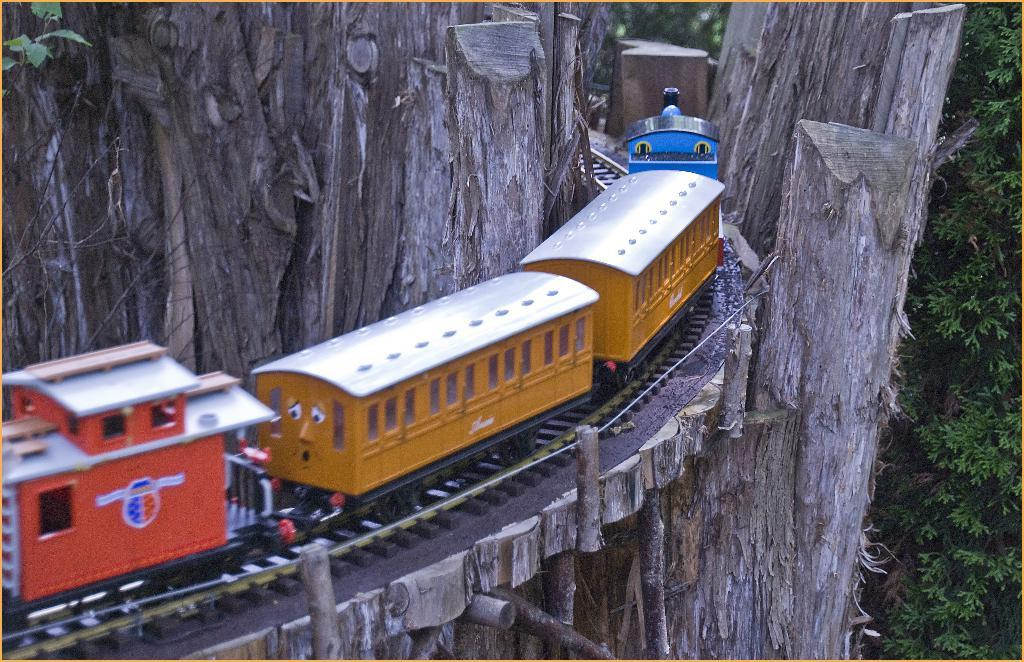What is the main subject of the image? There is a kids train in the image. What is the train doing in the image? The train is moving on a track. How is the track positioned in the image? The track is between tree trunks. What can be seen on the right side of the image? There are leaves on the right side of the image. What type of plants can be seen growing on the boundary of the image? There is no boundary or plants visible in the image; it features a kids train moving on a track between tree trunks. 